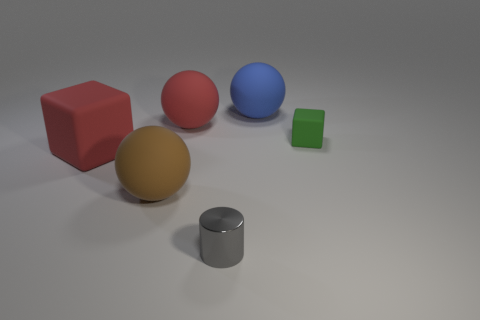Is there any other thing that has the same material as the tiny cylinder?
Your response must be concise. No. Do the red matte cube and the brown sphere have the same size?
Make the answer very short. Yes. What is the color of the tiny object to the right of the blue matte object?
Give a very brief answer. Green. Are there any rubber objects of the same color as the big matte cube?
Offer a terse response. Yes. The cylinder that is the same size as the green rubber cube is what color?
Ensure brevity in your answer.  Gray. Is the big brown object the same shape as the gray thing?
Provide a short and direct response. No. There is a tiny object to the right of the small cylinder; what is its material?
Provide a succinct answer. Rubber. The tiny metallic object is what color?
Your answer should be compact. Gray. There is a red object on the left side of the brown rubber object; does it have the same size as the sphere in front of the big red rubber block?
Your answer should be compact. Yes. What size is the matte sphere that is both to the left of the small metal cylinder and behind the red block?
Your response must be concise. Large. 